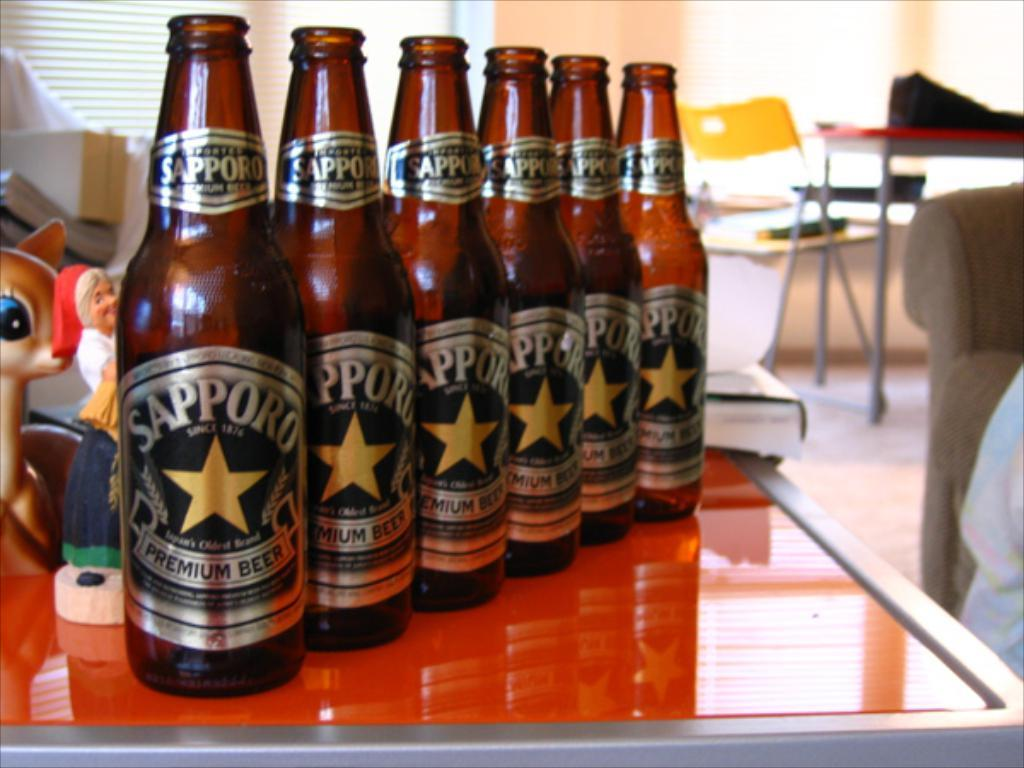Provide a one-sentence caption for the provided image. Six Sapporo Premium beers lined up on a table. 